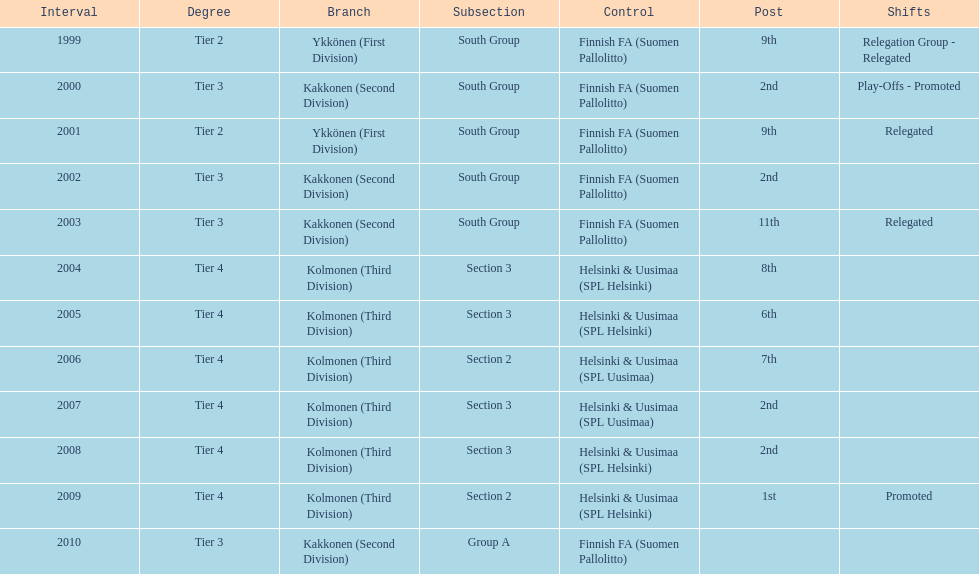Give me the full table as a dictionary. {'header': ['Interval', 'Degree', 'Branch', 'Subsection', 'Control', 'Post', 'Shifts'], 'rows': [['1999', 'Tier 2', 'Ykkönen (First Division)', 'South Group', 'Finnish FA (Suomen Pallolitto)', '9th', 'Relegation Group - Relegated'], ['2000', 'Tier 3', 'Kakkonen (Second Division)', 'South Group', 'Finnish FA (Suomen Pallolitto)', '2nd', 'Play-Offs - Promoted'], ['2001', 'Tier 2', 'Ykkönen (First Division)', 'South Group', 'Finnish FA (Suomen Pallolitto)', '9th', 'Relegated'], ['2002', 'Tier 3', 'Kakkonen (Second Division)', 'South Group', 'Finnish FA (Suomen Pallolitto)', '2nd', ''], ['2003', 'Tier 3', 'Kakkonen (Second Division)', 'South Group', 'Finnish FA (Suomen Pallolitto)', '11th', 'Relegated'], ['2004', 'Tier 4', 'Kolmonen (Third Division)', 'Section 3', 'Helsinki & Uusimaa (SPL Helsinki)', '8th', ''], ['2005', 'Tier 4', 'Kolmonen (Third Division)', 'Section 3', 'Helsinki & Uusimaa (SPL Helsinki)', '6th', ''], ['2006', 'Tier 4', 'Kolmonen (Third Division)', 'Section 2', 'Helsinki & Uusimaa (SPL Uusimaa)', '7th', ''], ['2007', 'Tier 4', 'Kolmonen (Third Division)', 'Section 3', 'Helsinki & Uusimaa (SPL Uusimaa)', '2nd', ''], ['2008', 'Tier 4', 'Kolmonen (Third Division)', 'Section 3', 'Helsinki & Uusimaa (SPL Helsinki)', '2nd', ''], ['2009', 'Tier 4', 'Kolmonen (Third Division)', 'Section 2', 'Helsinki & Uusimaa (SPL Helsinki)', '1st', 'Promoted'], ['2010', 'Tier 3', 'Kakkonen (Second Division)', 'Group A', 'Finnish FA (Suomen Pallolitto)', '', '']]} How many 2nd positions were there? 4. 